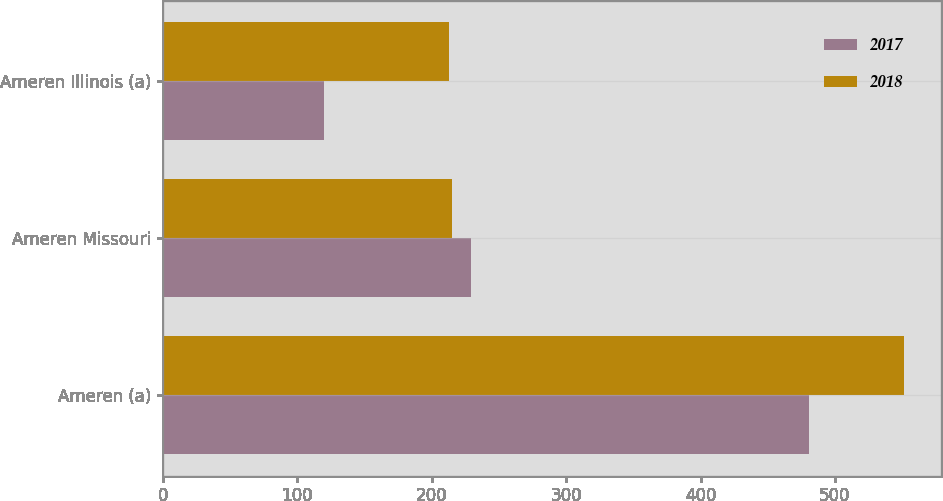Convert chart. <chart><loc_0><loc_0><loc_500><loc_500><stacked_bar_chart><ecel><fcel>Ameren (a)<fcel>Ameren Missouri<fcel>Ameren Illinois (a)<nl><fcel>2017<fcel>481<fcel>229<fcel>120<nl><fcel>2018<fcel>551<fcel>215<fcel>213<nl></chart> 